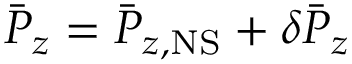<formula> <loc_0><loc_0><loc_500><loc_500>\bar { P } _ { z } = \bar { P } _ { z , N S } + \delta \bar { P } _ { z }</formula> 